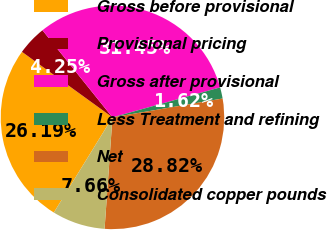<chart> <loc_0><loc_0><loc_500><loc_500><pie_chart><fcel>Gross before provisional<fcel>Provisional pricing<fcel>Gross after provisional<fcel>Less Treatment and refining<fcel>Net<fcel>Consolidated copper pounds<nl><fcel>26.19%<fcel>4.25%<fcel>31.45%<fcel>1.62%<fcel>28.82%<fcel>7.66%<nl></chart> 